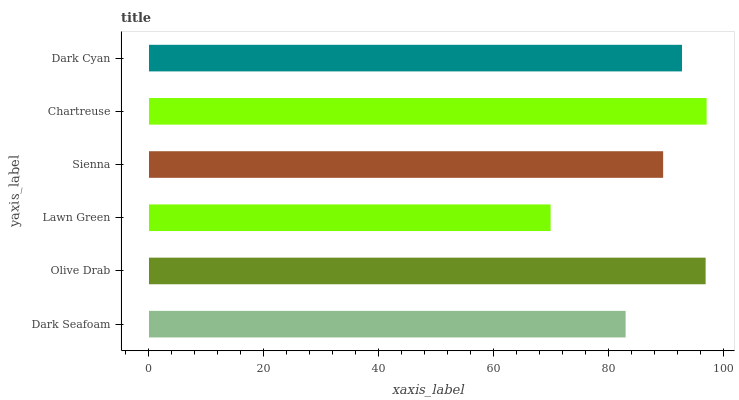Is Lawn Green the minimum?
Answer yes or no. Yes. Is Chartreuse the maximum?
Answer yes or no. Yes. Is Olive Drab the minimum?
Answer yes or no. No. Is Olive Drab the maximum?
Answer yes or no. No. Is Olive Drab greater than Dark Seafoam?
Answer yes or no. Yes. Is Dark Seafoam less than Olive Drab?
Answer yes or no. Yes. Is Dark Seafoam greater than Olive Drab?
Answer yes or no. No. Is Olive Drab less than Dark Seafoam?
Answer yes or no. No. Is Dark Cyan the high median?
Answer yes or no. Yes. Is Sienna the low median?
Answer yes or no. Yes. Is Lawn Green the high median?
Answer yes or no. No. Is Olive Drab the low median?
Answer yes or no. No. 